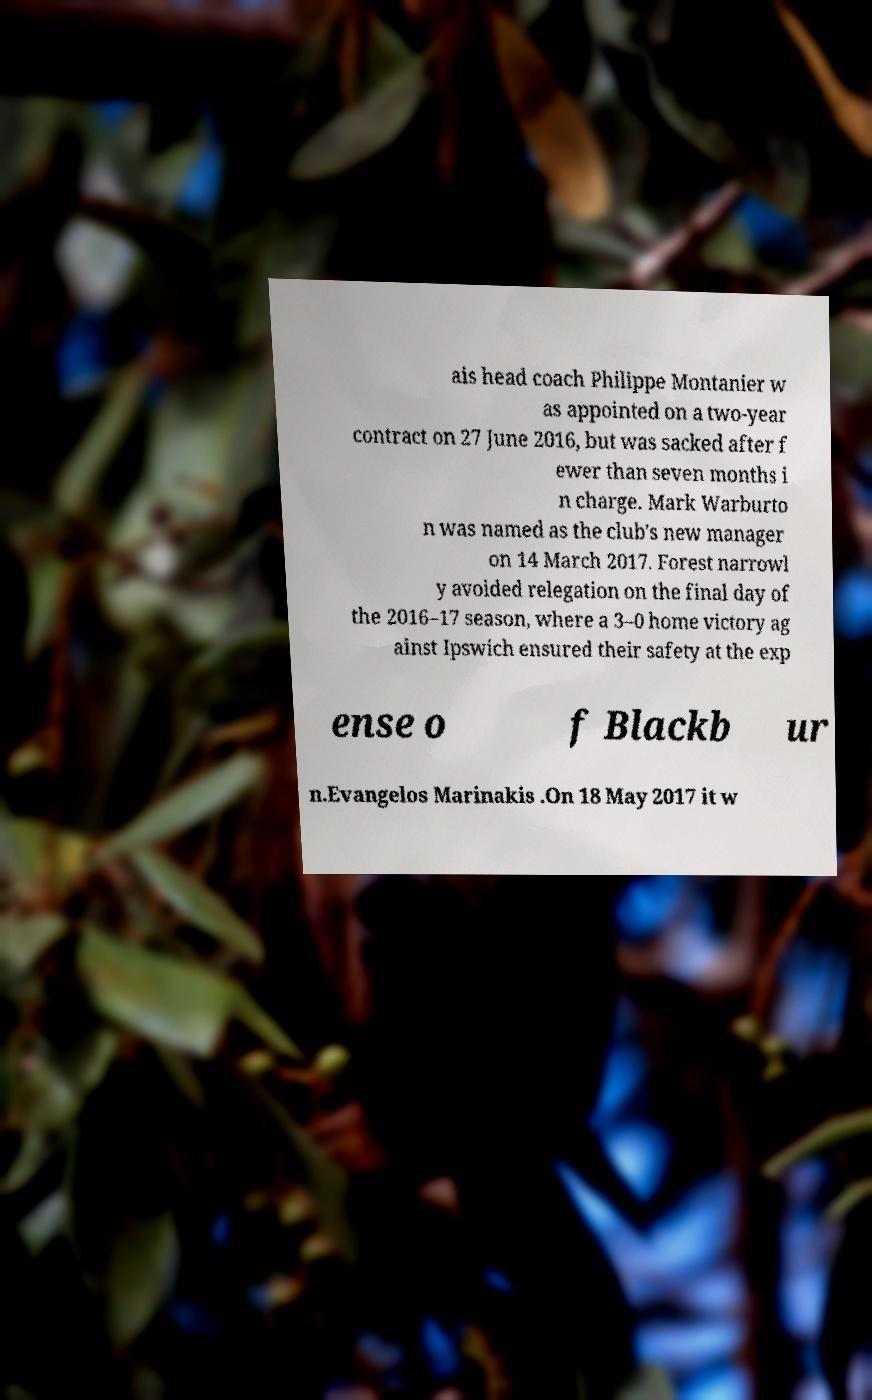Could you extract and type out the text from this image? ais head coach Philippe Montanier w as appointed on a two-year contract on 27 June 2016, but was sacked after f ewer than seven months i n charge. Mark Warburto n was named as the club's new manager on 14 March 2017. Forest narrowl y avoided relegation on the final day of the 2016–17 season, where a 3–0 home victory ag ainst Ipswich ensured their safety at the exp ense o f Blackb ur n.Evangelos Marinakis .On 18 May 2017 it w 